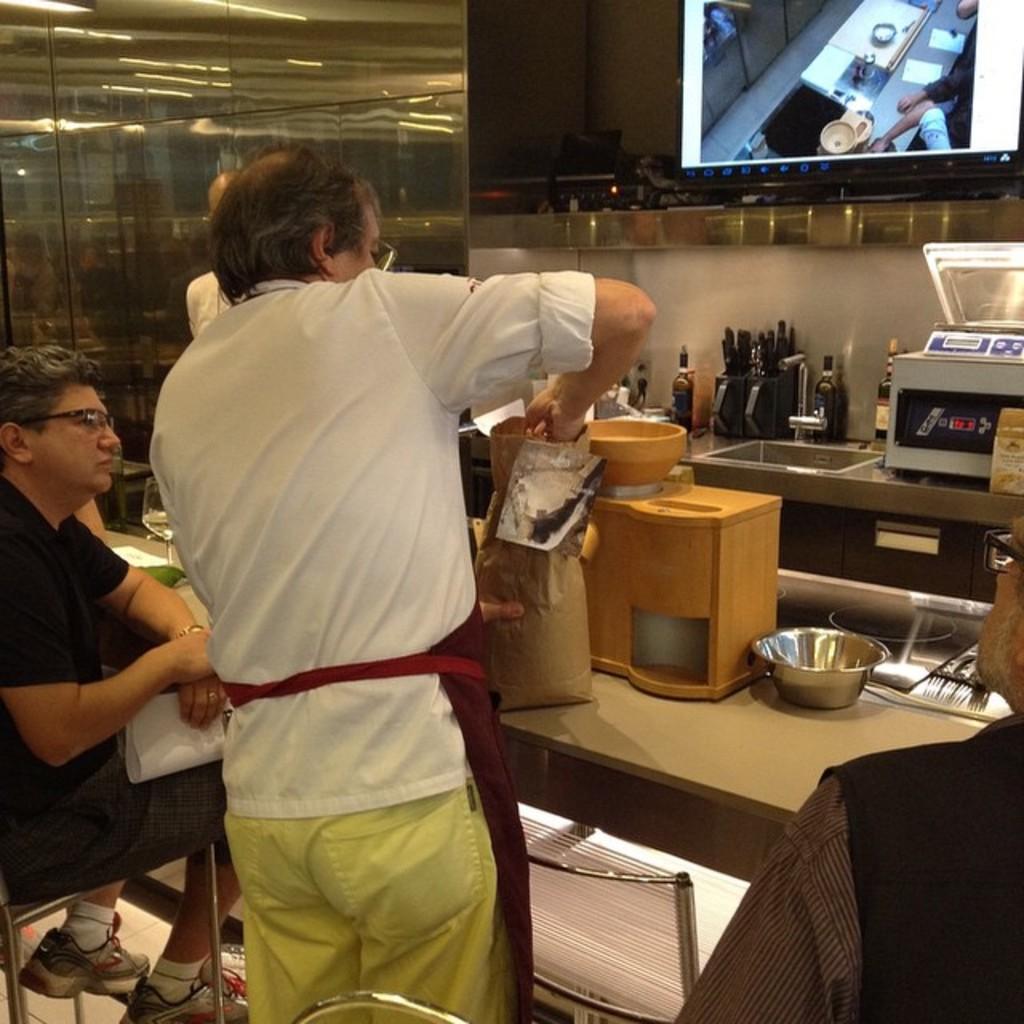Please provide a concise description of this image. In this image I can see few people where a man is sitting and another one is standing. In the background I can see utensils and a screen. 